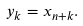Convert formula to latex. <formula><loc_0><loc_0><loc_500><loc_500>y _ { k } = x _ { n + k } .</formula> 